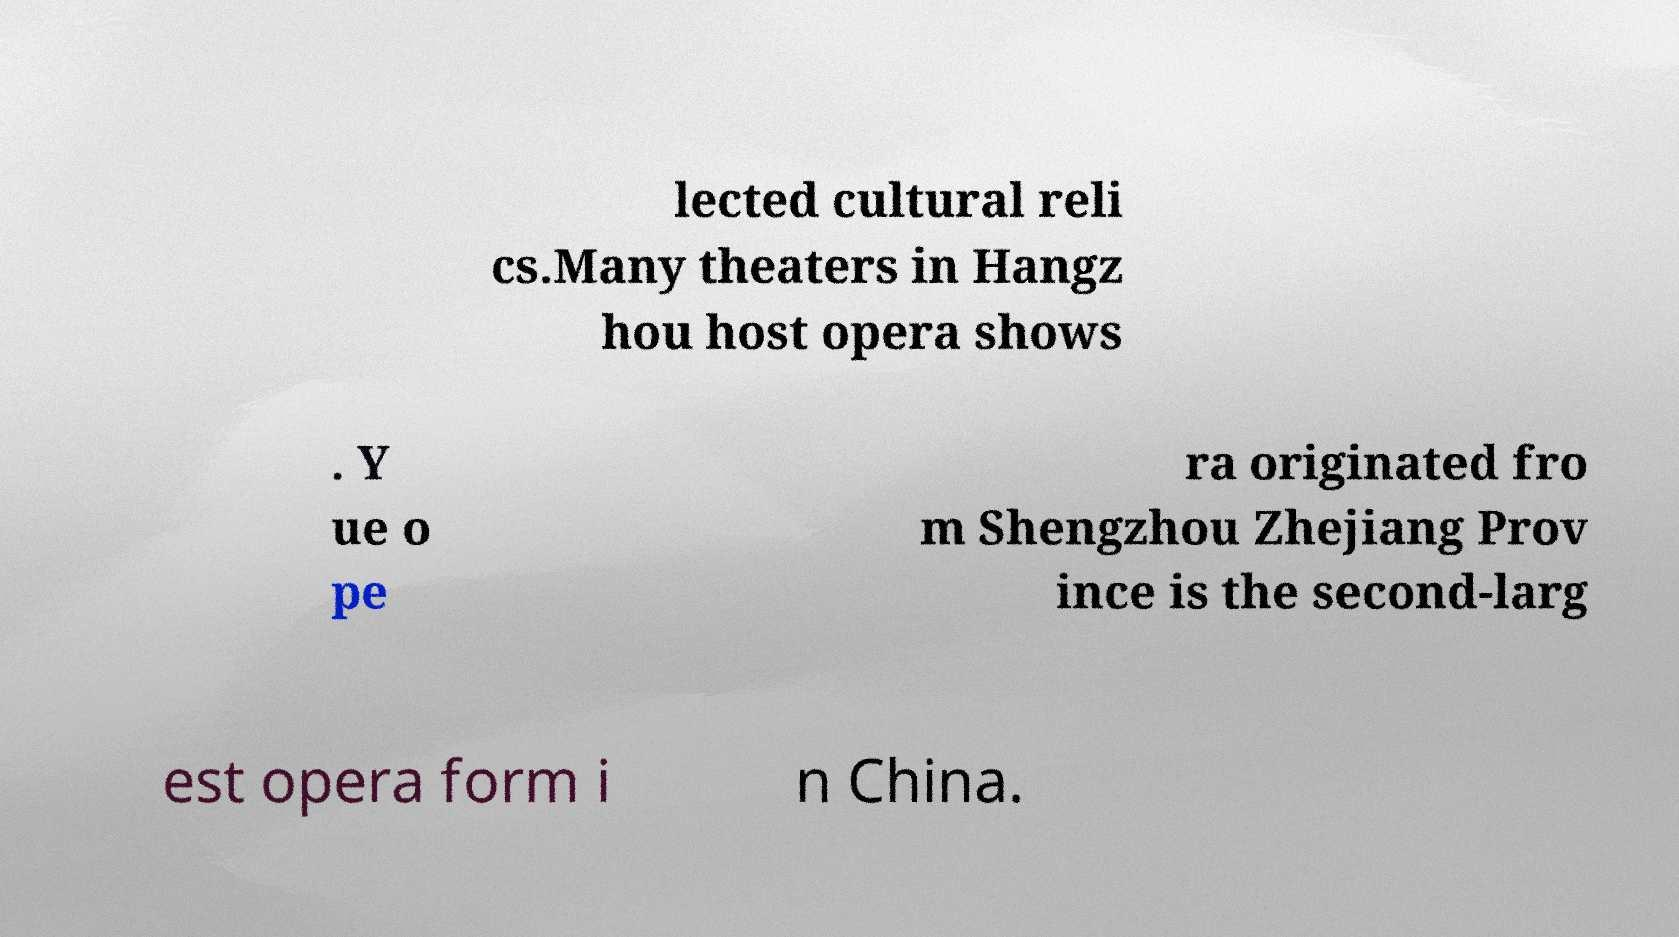Please identify and transcribe the text found in this image. lected cultural reli cs.Many theaters in Hangz hou host opera shows . Y ue o pe ra originated fro m Shengzhou Zhejiang Prov ince is the second-larg est opera form i n China. 